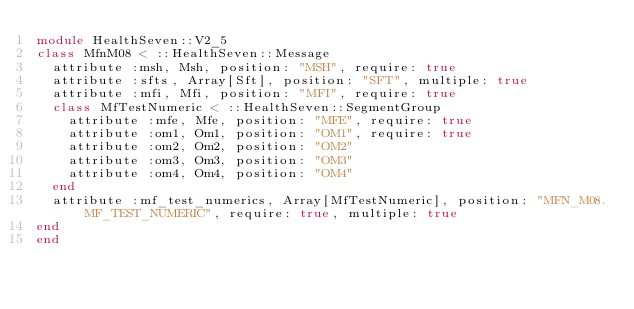Convert code to text. <code><loc_0><loc_0><loc_500><loc_500><_Ruby_>module HealthSeven::V2_5
class MfnM08 < ::HealthSeven::Message
  attribute :msh, Msh, position: "MSH", require: true
  attribute :sfts, Array[Sft], position: "SFT", multiple: true
  attribute :mfi, Mfi, position: "MFI", require: true
  class MfTestNumeric < ::HealthSeven::SegmentGroup
    attribute :mfe, Mfe, position: "MFE", require: true
    attribute :om1, Om1, position: "OM1", require: true
    attribute :om2, Om2, position: "OM2"
    attribute :om3, Om3, position: "OM3"
    attribute :om4, Om4, position: "OM4"
  end
  attribute :mf_test_numerics, Array[MfTestNumeric], position: "MFN_M08.MF_TEST_NUMERIC", require: true, multiple: true
end
end</code> 